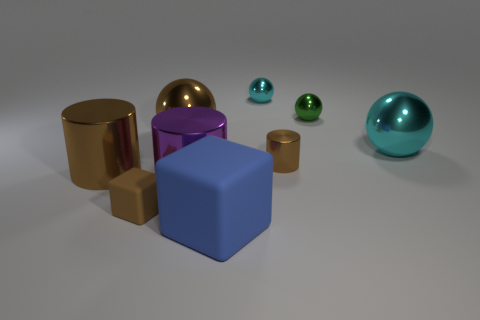There is a tiny thing that is the same color as the tiny rubber cube; what shape is it?
Provide a succinct answer. Cylinder. There is a small green sphere; how many balls are behind it?
Your response must be concise. 1. What material is the tiny thing that is on the left side of the rubber object that is right of the small brown rubber object made of?
Your answer should be compact. Rubber. Are there any tiny metal objects of the same color as the small matte block?
Give a very brief answer. Yes. There is a green ball that is made of the same material as the small brown cylinder; what is its size?
Your answer should be very brief. Small. Are there any other things that have the same color as the large cube?
Make the answer very short. No. What is the color of the large object that is to the right of the blue block?
Keep it short and to the point. Cyan. There is a cyan shiny thing that is behind the cyan metal thing that is in front of the big brown ball; are there any metallic spheres to the left of it?
Your response must be concise. Yes. Are there more big metal things right of the brown block than purple things?
Keep it short and to the point. Yes. There is a thing behind the small green object; does it have the same shape as the big cyan metal object?
Give a very brief answer. Yes. 